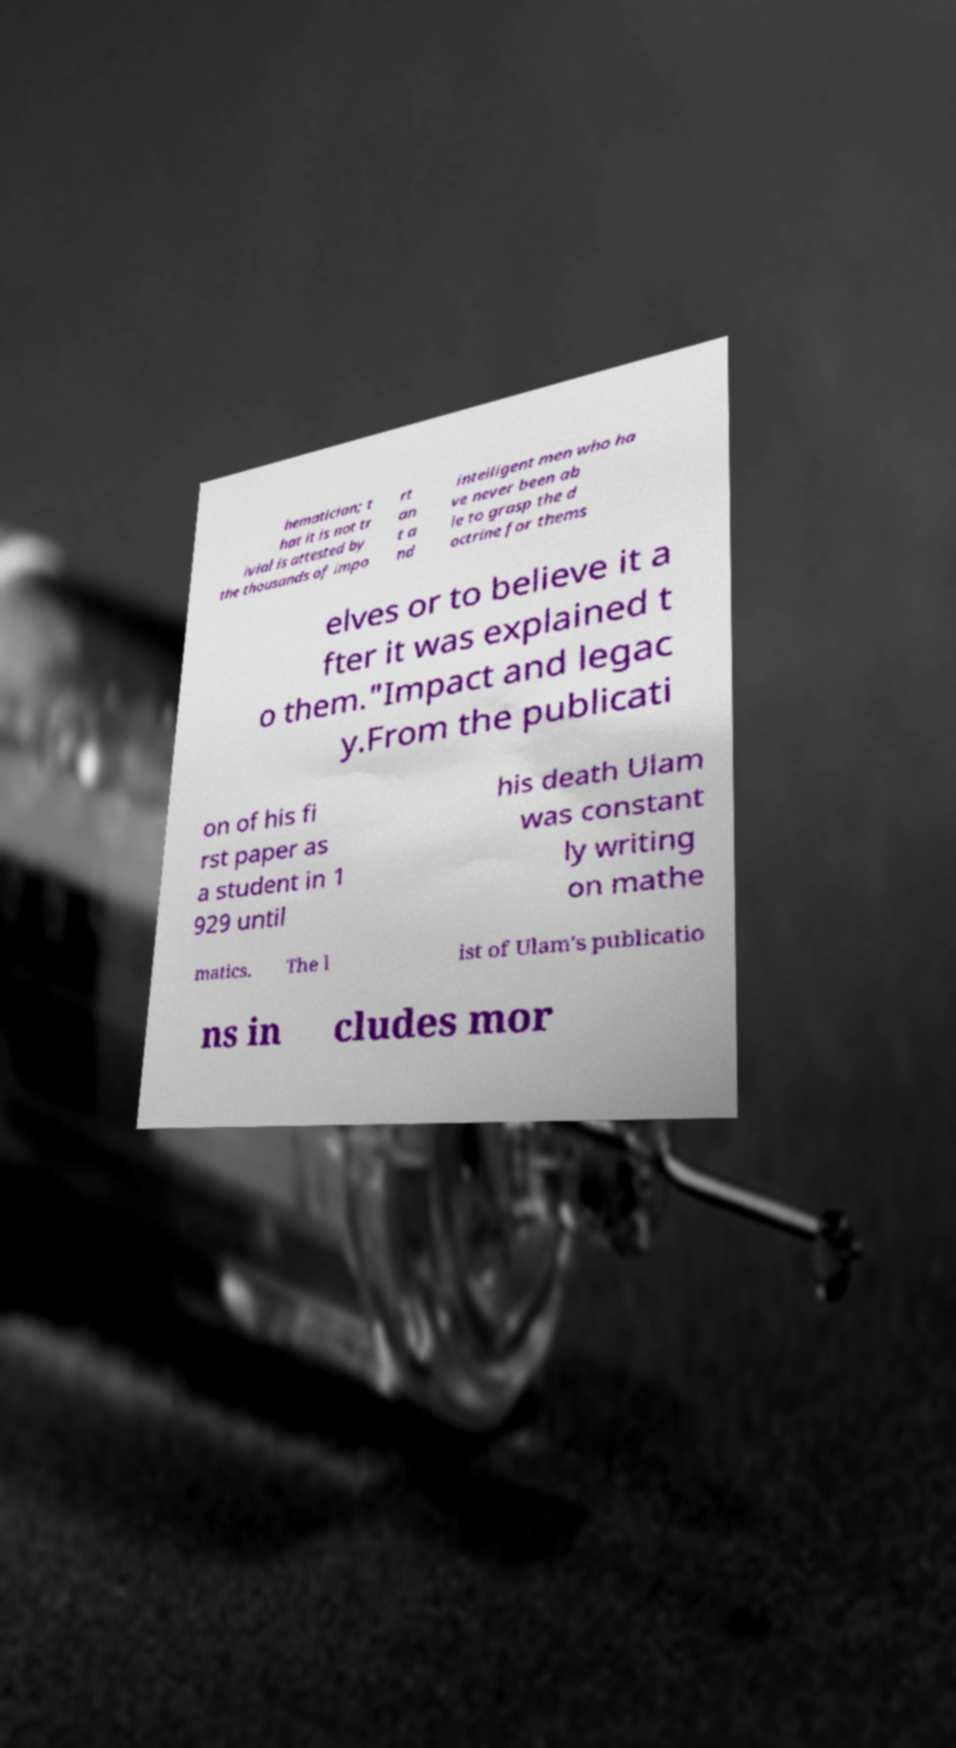Please read and relay the text visible in this image. What does it say? hematician; t hat it is not tr ivial is attested by the thousands of impo rt an t a nd intelligent men who ha ve never been ab le to grasp the d octrine for thems elves or to believe it a fter it was explained t o them."Impact and legac y.From the publicati on of his fi rst paper as a student in 1 929 until his death Ulam was constant ly writing on mathe matics. The l ist of Ulam's publicatio ns in cludes mor 